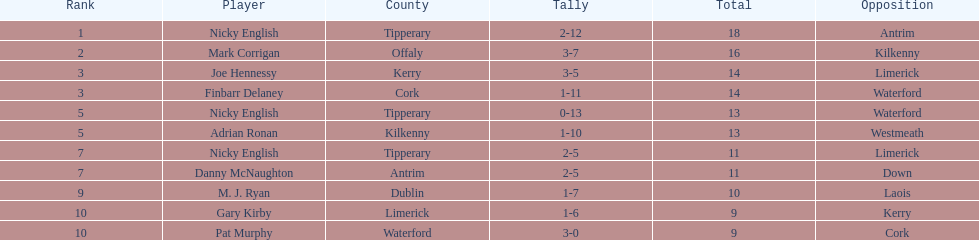If you added all the total's up, what would the number be? 138. 